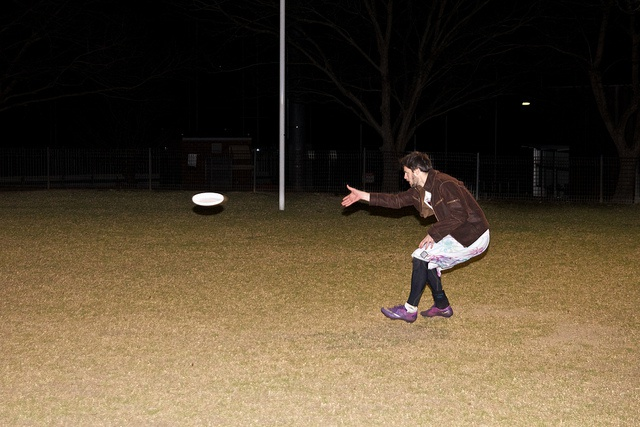Describe the objects in this image and their specific colors. I can see people in black, maroon, lightgray, and brown tones and frisbee in black, white, darkgray, and gray tones in this image. 